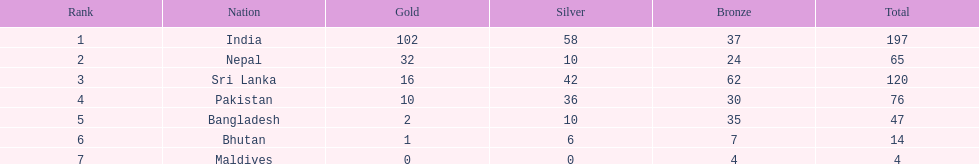What is the complete count of bronze medals obtained by sri lanka? 62. 